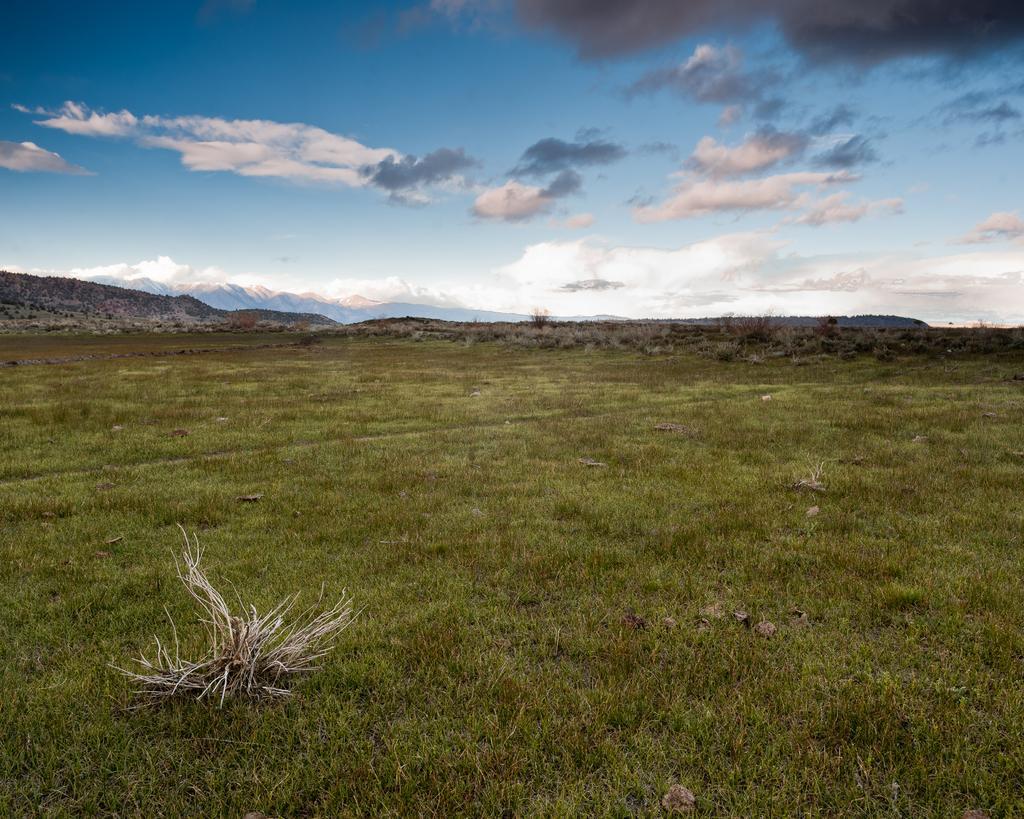How would you summarize this image in a sentence or two? This picture is clicked outside the city. In the foreground we can see the ground is covered with the green grass. In the background we can see the hills and the sky which is full of clouds. 